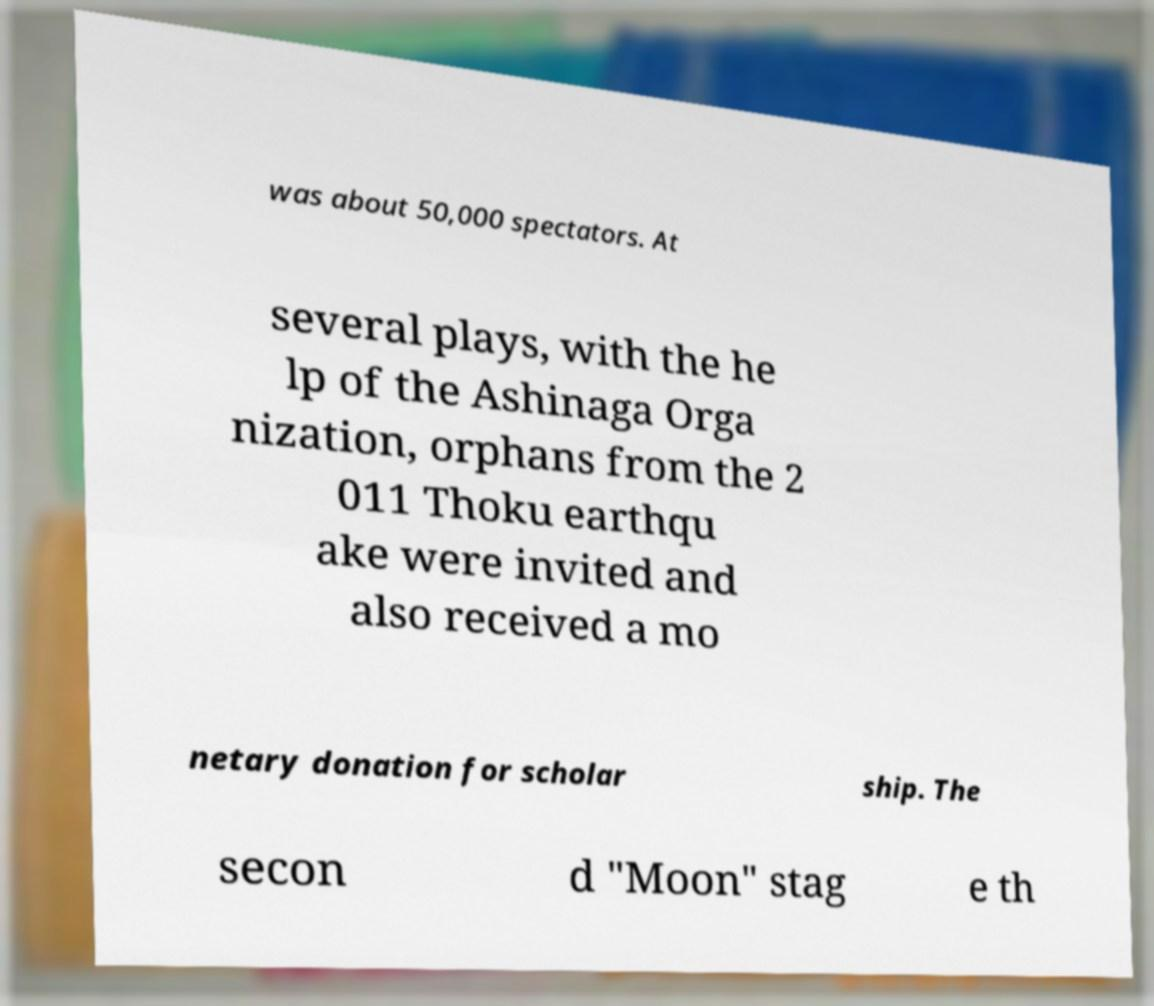Please read and relay the text visible in this image. What does it say? was about 50,000 spectators. At several plays, with the he lp of the Ashinaga Orga nization, orphans from the 2 011 Thoku earthqu ake were invited and also received a mo netary donation for scholar ship. The secon d "Moon" stag e th 